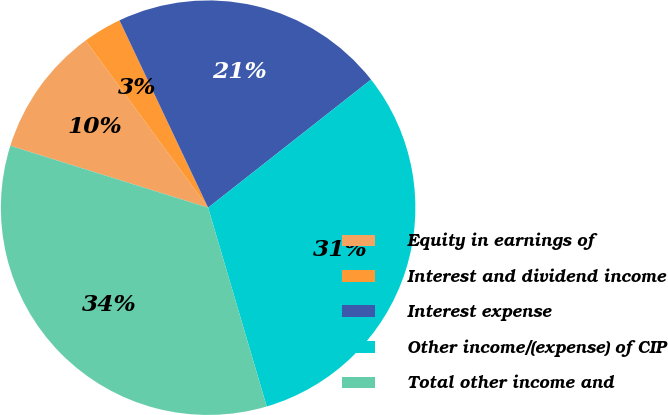Convert chart. <chart><loc_0><loc_0><loc_500><loc_500><pie_chart><fcel>Equity in earnings of<fcel>Interest and dividend income<fcel>Interest expense<fcel>Other income/(expense) of CIP<fcel>Total other income and<nl><fcel>10.11%<fcel>3.03%<fcel>21.43%<fcel>31.04%<fcel>34.39%<nl></chart> 